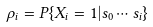Convert formula to latex. <formula><loc_0><loc_0><loc_500><loc_500>\rho _ { i } = P \{ X _ { i } = 1 | s _ { 0 } \cdots s _ { i } \}</formula> 